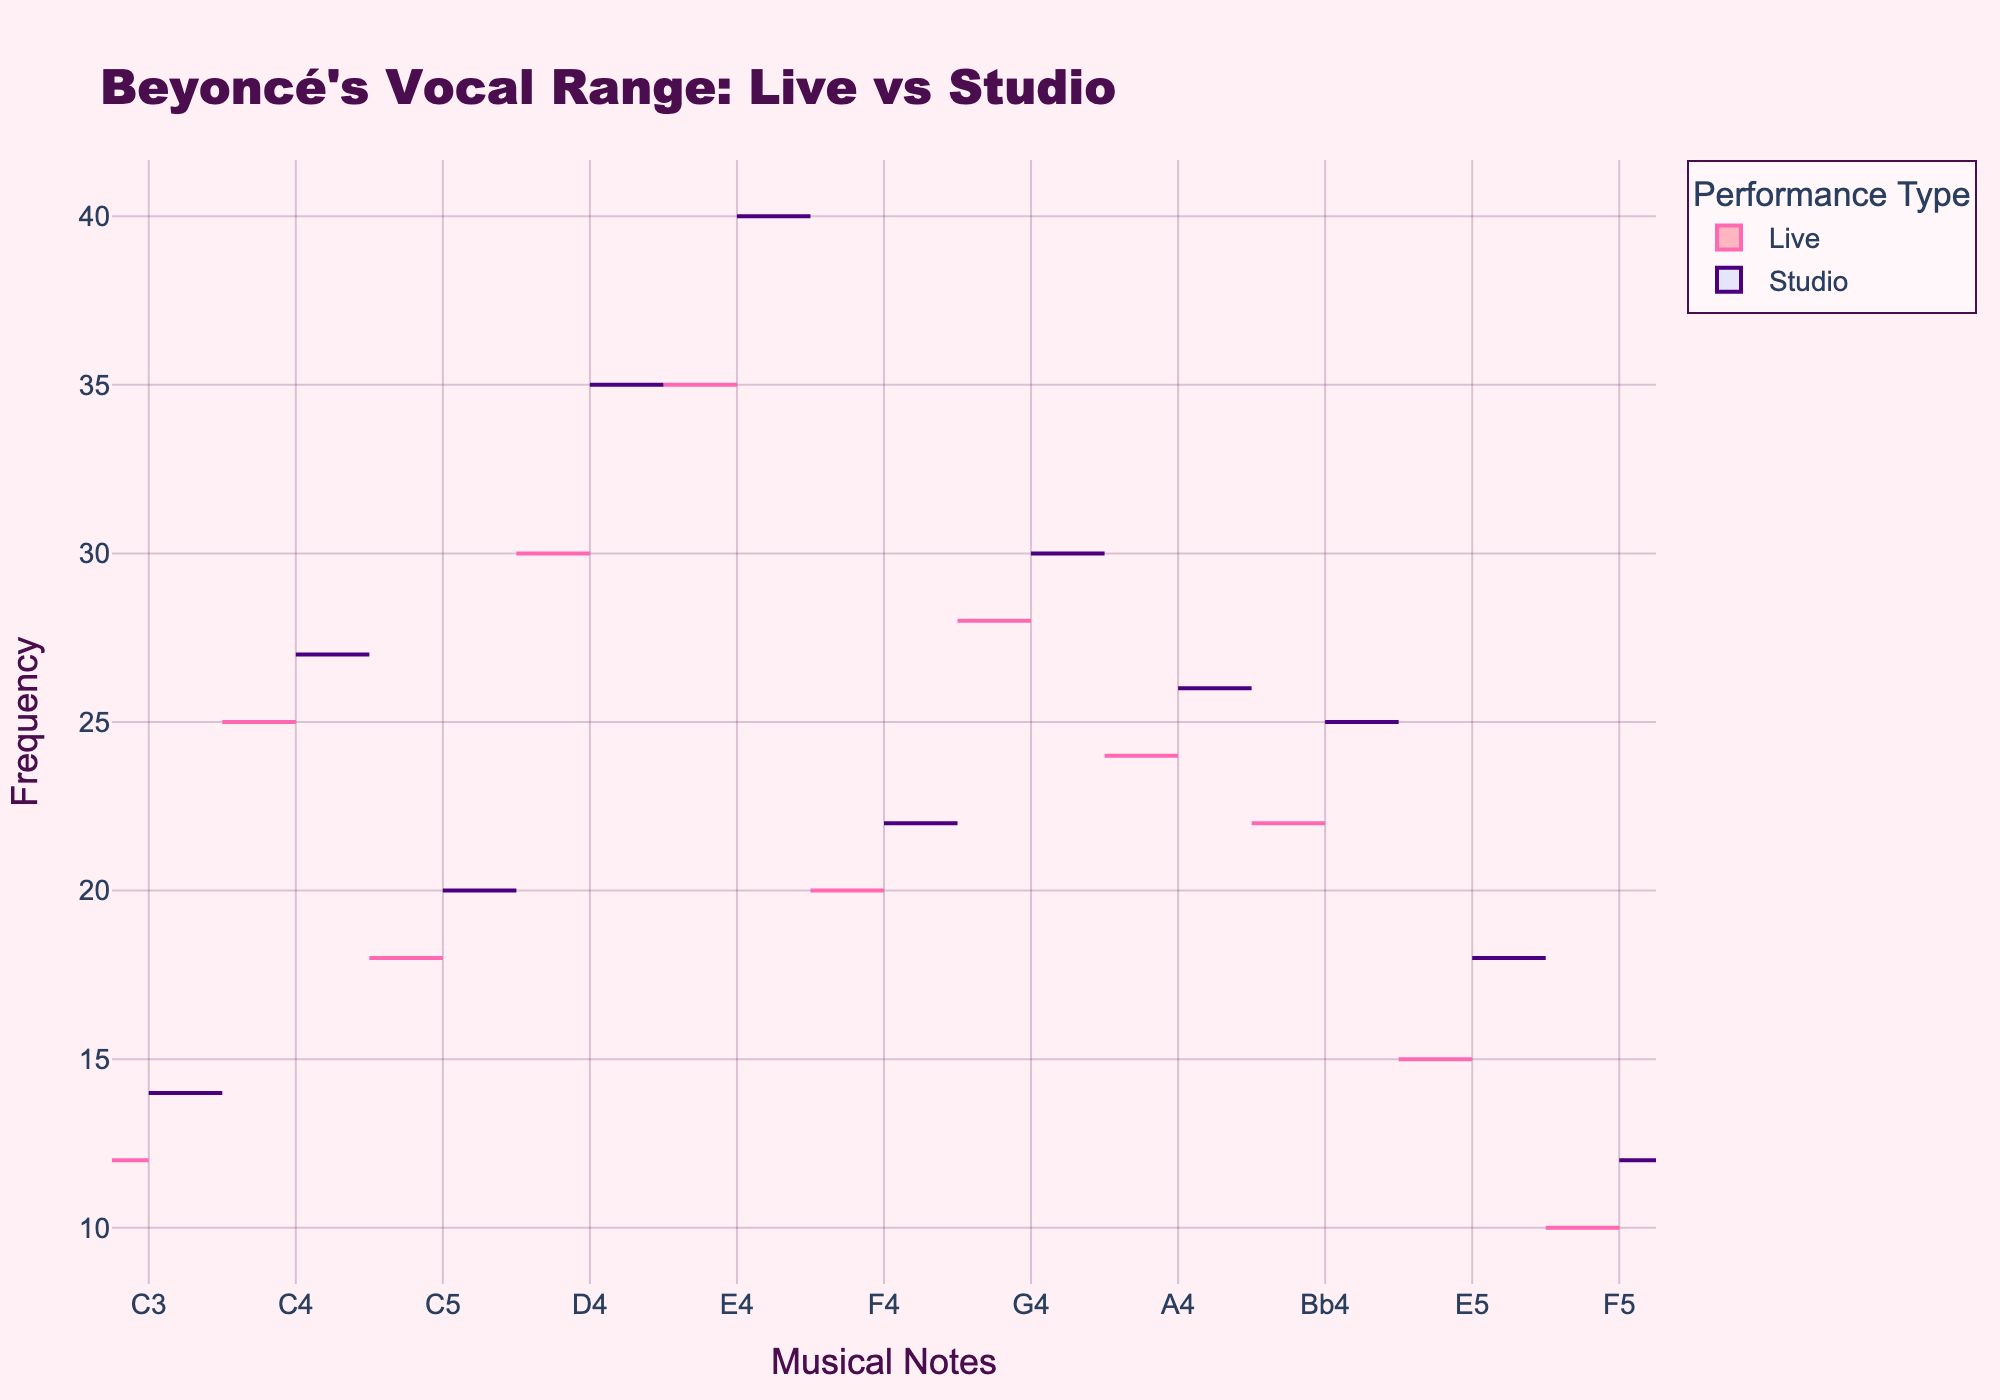What is the title of the chart? The title is displayed at the top of the chart. It reads: "Beyoncé's Vocal Range: Live vs Studio".
Answer: Beyoncé's Vocal Range: Live vs Studio What are the x and y-axis labels? The x-axis label represents the musical notes used in the performances, while the y-axis label represents the frequency of those notes.
Answer: x-axis: Musical Notes, y-axis: Frequency Which note has the highest frequency in studio recordings? By observing the width of the violin plot on the positive side, the widest section corresponds to the note E4, indicating it has the highest frequency.
Answer: E4 Which range of notes shows a higher frequency in live performances compared to studio recordings? By comparing the width and location of the violin plots on both sides for each note, we see that the notes C3, C4, and E4 show a higher frequency in live performances than in studio recordings.
Answer: C3, C4, E4 What note appears equally in both live and studio recordings? From the chart, the note that has similar widths on both the negative and positive sides of the violin plot is F4.
Answer: F4 Is the frequency of G4 higher in live or studio recordings? By comparing the width of the violin plot for the note G4, it's evident that the studio recording (positive side) is wider than in live performances (negative side), indicating a higher frequency in studio recordings.
Answer: Studio What is the combined frequency of the note D4 in both live and studio recordings? Summing the frequencies from the data: Live (30) and Studio (35), gives a combined frequency.
Answer: 65 Which note is more frequently used in live performances than in studio recordings, and by how much? From the chart, note C3 in live performances (12) appears slightly less than in studio recordings (14). Note E4 is more frequent in live performances (35) than in studio (40), so the other notes need examining. The most significant difference is for D4.
Answer: No such note Can you identify the notes where the frequencies differ by at least 5 between live and studio recordings? Examining the differences: C3 (2), C4 (2), C5 (2), D4 (5), E4 (5), F4 (2), G4 (2), A4 (2), Bb4 (3), C5 (2), E5 (3), F5 (2). The notes D4 and E4 meet the criteria.
Answer: D4, E4 Which note exhibits the smallest difference in frequency between live and studio recordings? By comparing the frequencies: note F5 in live performances (10) and in studio recordings (12) has the smallest difference, which is 2.
Answer: F5 